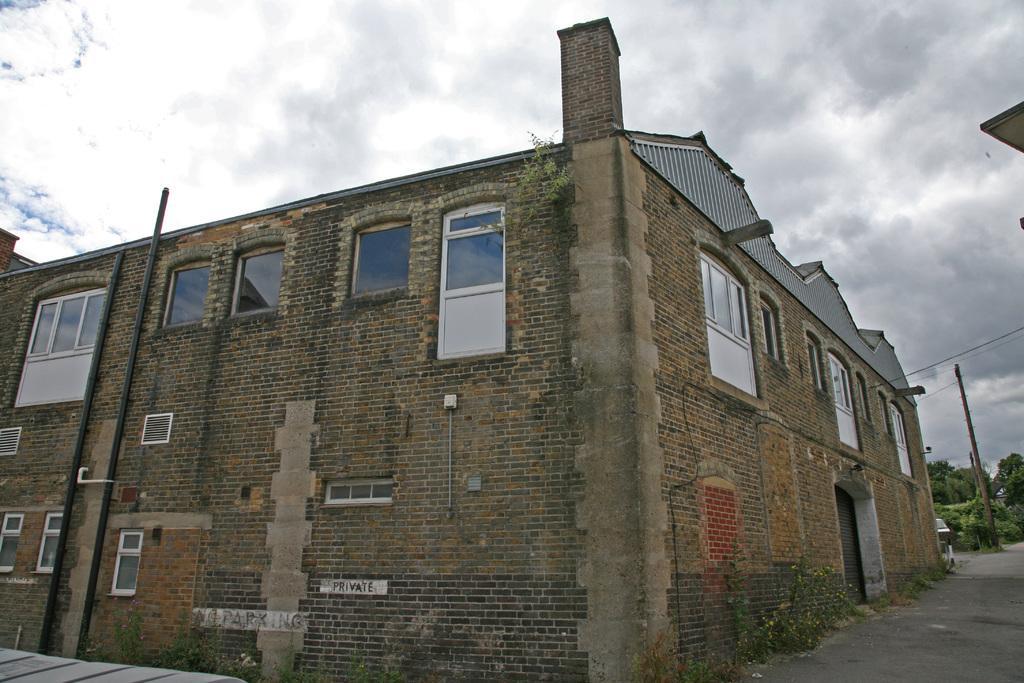In one or two sentences, can you explain what this image depicts? In the image there is a building with brick walls, glass windows, pipes, roofs and also there is a chimney. On the right corner of the image behind the building there are trees and poles. At the top of the image there is sky with clouds. 